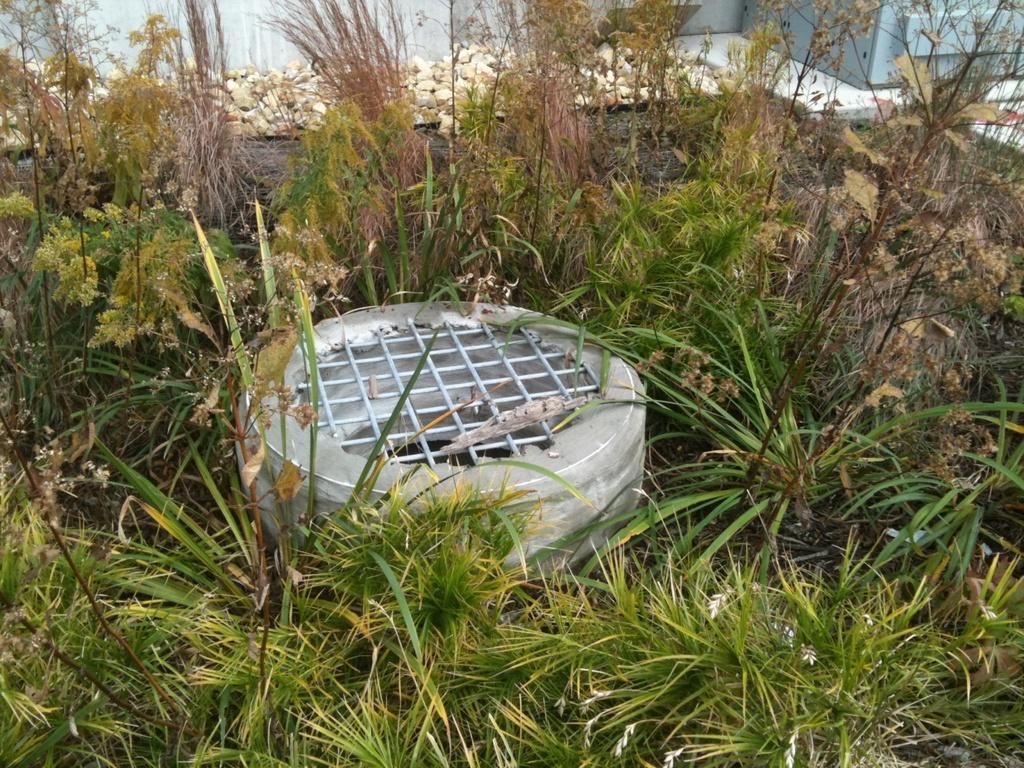Could you give a brief overview of what you see in this image? In this picture I can see the hole, beside that I can see the plants and grass. At the top of the hole I can see the steel object. At the top I can see the stones near to the wall. In the top right corner there is cupboard which is placed near to the wall. 